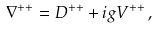Convert formula to latex. <formula><loc_0><loc_0><loc_500><loc_500>\nabla ^ { + + } = D ^ { + + } + i g V ^ { + + } \, ,</formula> 